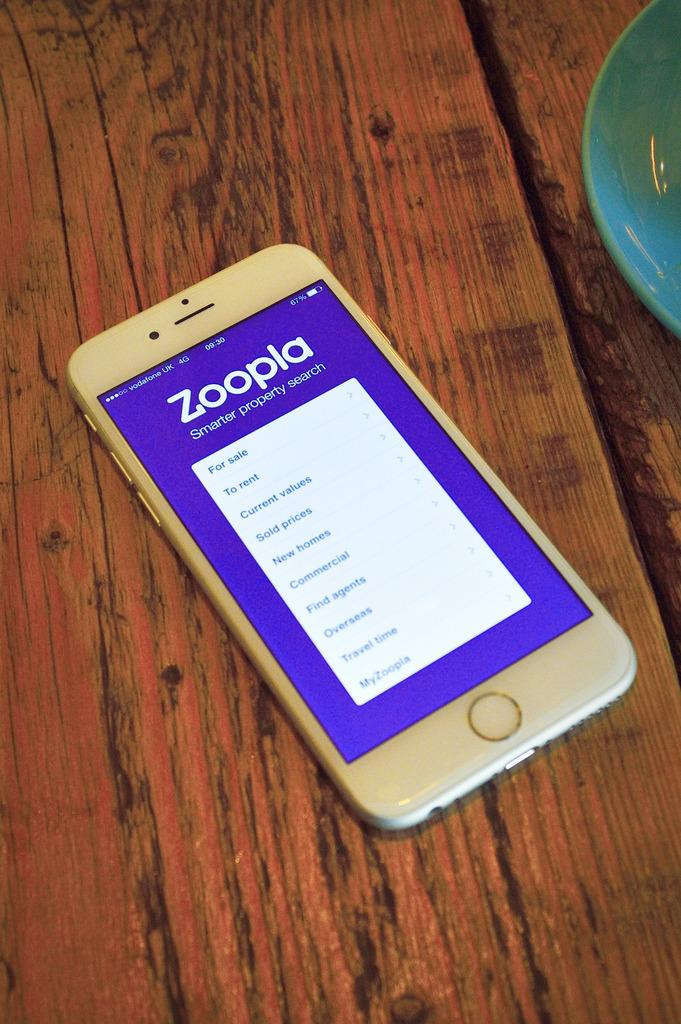<image>
Offer a succinct explanation of the picture presented. a white front faced iphone with a page on the screen that says 'zoopla' 